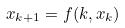Convert formula to latex. <formula><loc_0><loc_0><loc_500><loc_500>x _ { k + 1 } = f ( k , x _ { k } )</formula> 